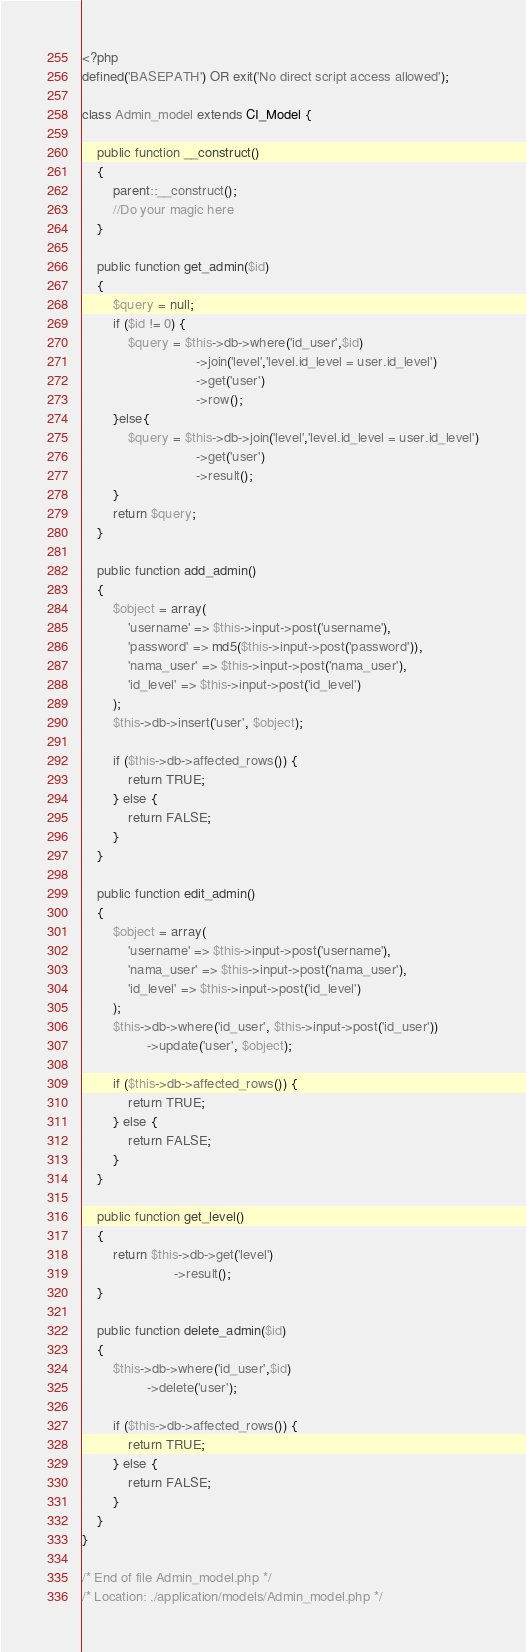Convert code to text. <code><loc_0><loc_0><loc_500><loc_500><_PHP_><?php
defined('BASEPATH') OR exit('No direct script access allowed');

class Admin_model extends CI_Model {

	public function __construct()
	{
		parent::__construct();
		//Do your magic here
	}

	public function get_admin($id)
	{
		$query = null;
		if ($id != 0) {
			$query = $this->db->where('id_user',$id)
							  ->join('level','level.id_level = user.id_level')
							  ->get('user')
							  ->row();
		}else{
			$query = $this->db->join('level','level.id_level = user.id_level')
							  ->get('user')
							  ->result();
		}
		return $query;
	}

	public function add_admin()
	{
		$object = array(
			'username' => $this->input->post('username'),
			'password' => md5($this->input->post('password')),
			'nama_user' => $this->input->post('nama_user'),
			'id_level' => $this->input->post('id_level')
		);
		$this->db->insert('user', $object);

		if ($this->db->affected_rows()) {
			return TRUE;
		} else {
			return FALSE;
		}
	}

	public function edit_admin()
	{
		$object = array(
			'username' => $this->input->post('username'),
			'nama_user' => $this->input->post('nama_user'),
			'id_level' => $this->input->post('id_level')
		);
		$this->db->where('id_user', $this->input->post('id_user'))
				 ->update('user', $object);

		if ($this->db->affected_rows()) {
			return TRUE;
		} else {
			return FALSE;
		}
	}

	public function get_level()
	{
		return $this->db->get('level')
						->result();
	}

	public function delete_admin($id)
	{
		$this->db->where('id_user',$id)
				 ->delete('user');

		if ($this->db->affected_rows()) {
			return TRUE;
		} else {
			return FALSE;
		}
	}
}

/* End of file Admin_model.php */
/* Location: ./application/models/Admin_model.php */</code> 